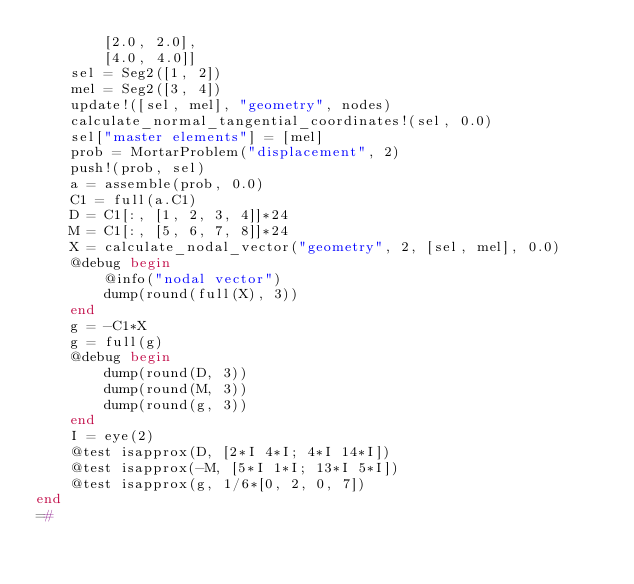<code> <loc_0><loc_0><loc_500><loc_500><_Julia_>        [2.0, 2.0],
        [4.0, 4.0]]
    sel = Seg2([1, 2])
    mel = Seg2([3, 4])
    update!([sel, mel], "geometry", nodes)
    calculate_normal_tangential_coordinates!(sel, 0.0)
    sel["master elements"] = [mel]
    prob = MortarProblem("displacement", 2)
    push!(prob, sel)
    a = assemble(prob, 0.0)
    C1 = full(a.C1)
    D = C1[:, [1, 2, 3, 4]]*24
    M = C1[:, [5, 6, 7, 8]]*24
    X = calculate_nodal_vector("geometry", 2, [sel, mel], 0.0)
    @debug begin
        @info("nodal vector")
        dump(round(full(X), 3))
    end
    g = -C1*X
    g = full(g)
    @debug begin
        dump(round(D, 3))
        dump(round(M, 3))
        dump(round(g, 3))
    end
    I = eye(2)
    @test isapprox(D, [2*I 4*I; 4*I 14*I])
    @test isapprox(-M, [5*I 1*I; 13*I 5*I])
    @test isapprox(g, 1/6*[0, 2, 0, 7])
end
=#
</code> 